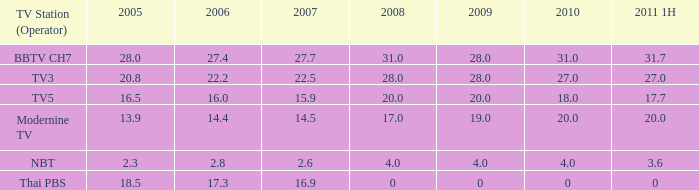What is the maximum 1h value in 2011 for a 2005 model with over 28? None. 